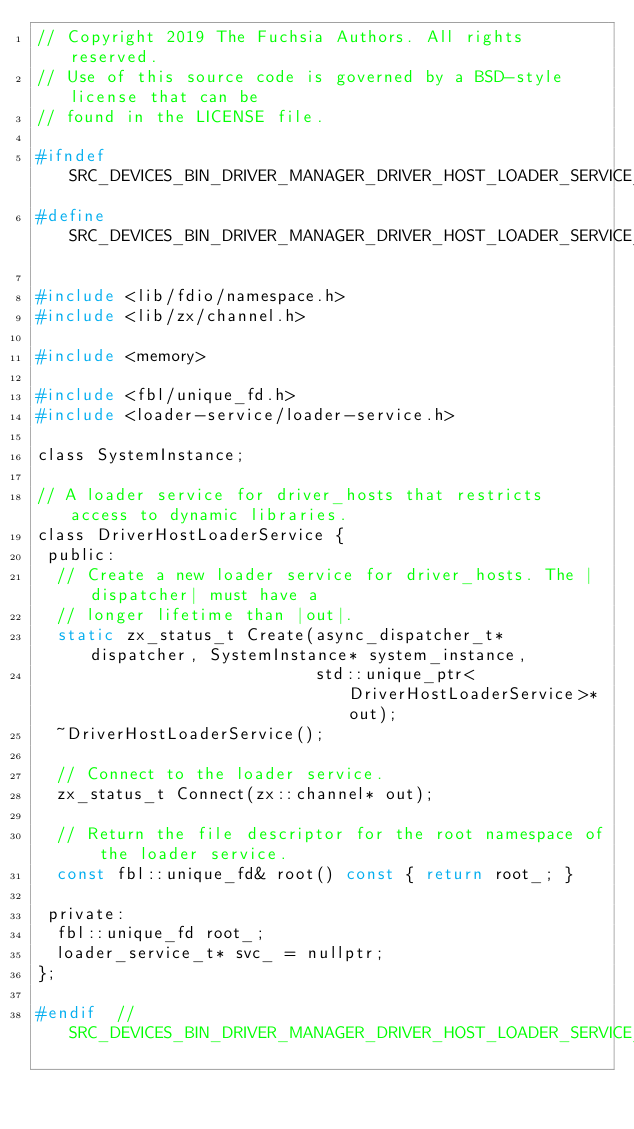<code> <loc_0><loc_0><loc_500><loc_500><_C_>// Copyright 2019 The Fuchsia Authors. All rights reserved.
// Use of this source code is governed by a BSD-style license that can be
// found in the LICENSE file.

#ifndef SRC_DEVICES_BIN_DRIVER_MANAGER_DRIVER_HOST_LOADER_SERVICE_H_
#define SRC_DEVICES_BIN_DRIVER_MANAGER_DRIVER_HOST_LOADER_SERVICE_H_

#include <lib/fdio/namespace.h>
#include <lib/zx/channel.h>

#include <memory>

#include <fbl/unique_fd.h>
#include <loader-service/loader-service.h>

class SystemInstance;

// A loader service for driver_hosts that restricts access to dynamic libraries.
class DriverHostLoaderService {
 public:
  // Create a new loader service for driver_hosts. The |dispatcher| must have a
  // longer lifetime than |out|.
  static zx_status_t Create(async_dispatcher_t* dispatcher, SystemInstance* system_instance,
                            std::unique_ptr<DriverHostLoaderService>* out);
  ~DriverHostLoaderService();

  // Connect to the loader service.
  zx_status_t Connect(zx::channel* out);

  // Return the file descriptor for the root namespace of the loader service.
  const fbl::unique_fd& root() const { return root_; }

 private:
  fbl::unique_fd root_;
  loader_service_t* svc_ = nullptr;
};

#endif  // SRC_DEVICES_BIN_DRIVER_MANAGER_DRIVER_HOST_LOADER_SERVICE_H_
</code> 